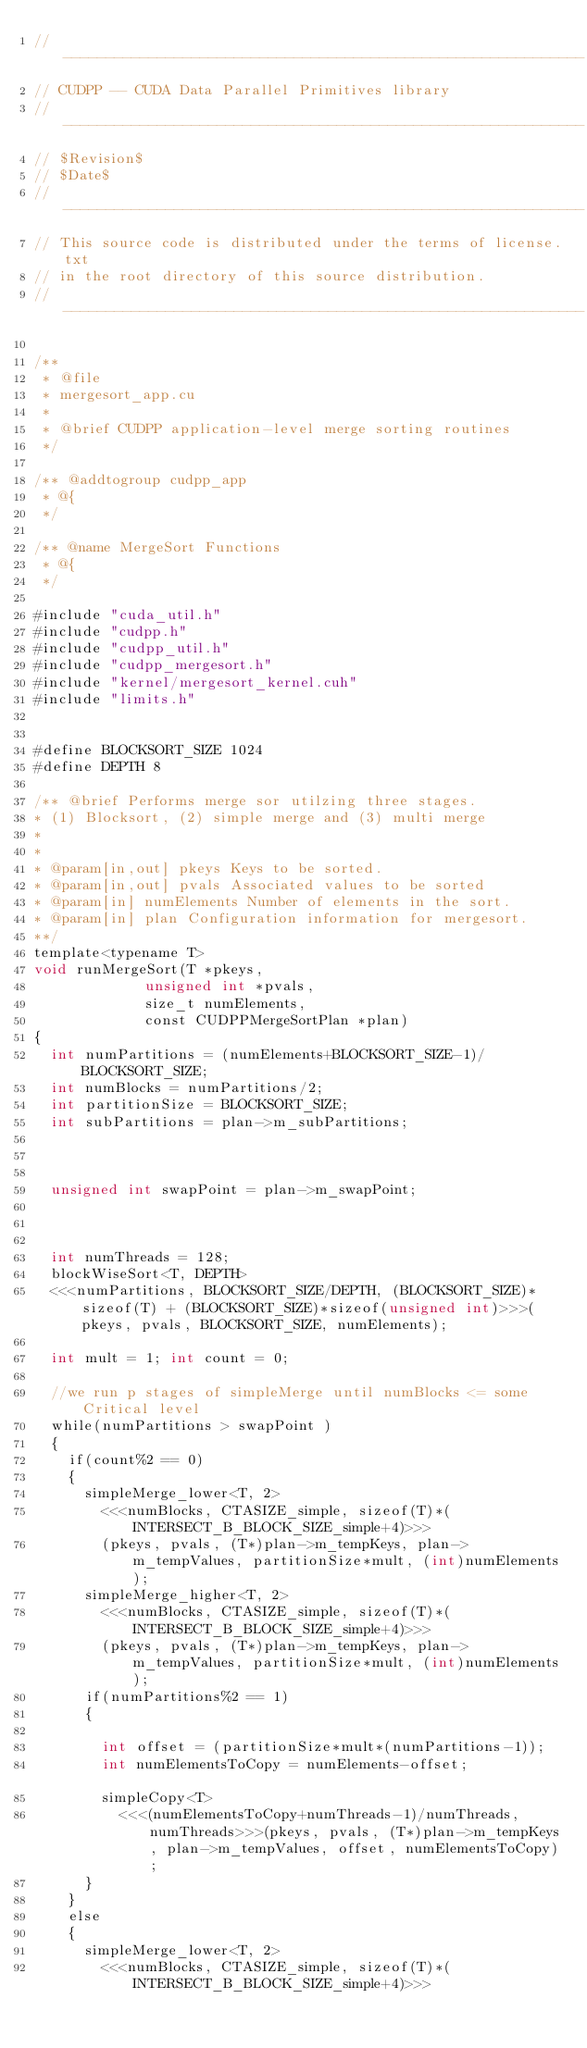<code> <loc_0><loc_0><loc_500><loc_500><_Cuda_>// -------------------------------------------------------------
// CUDPP -- CUDA Data Parallel Primitives library
// -------------------------------------------------------------
// $Revision$
// $Date$
// ------------------------------------------------------------- 
// This source code is distributed under the terms of license.txt 
// in the root directory of this source distribution.
// ------------------------------------------------------------- 

/**
 * @file
 * mergesort_app.cu
 *   
 * @brief CUDPP application-level merge sorting routines
 */

/** @addtogroup cudpp_app 
 * @{
 */

/** @name MergeSort Functions
 * @{
 */
 
#include "cuda_util.h"
#include "cudpp.h"
#include "cudpp_util.h"
#include "cudpp_mergesort.h"
#include "kernel/mergesort_kernel.cuh"
#include "limits.h"


#define BLOCKSORT_SIZE 1024
#define DEPTH 8

/** @brief Performs merge sor utilzing three stages. 
* (1) Blocksort, (2) simple merge and (3) multi merge
* 
* 
* @param[in,out] pkeys Keys to be sorted.
* @param[in,out] pvals Associated values to be sorted
* @param[in] numElements Number of elements in the sort.
* @param[in] plan Configuration information for mergesort.
**/
template<typename T>
void runMergeSort(T *pkeys, 
             unsigned int *pvals,
             size_t numElements, 
             const CUDPPMergeSortPlan *plan)
{
	int numPartitions = (numElements+BLOCKSORT_SIZE-1)/BLOCKSORT_SIZE;
	int numBlocks = numPartitions/2;
	int partitionSize = BLOCKSORT_SIZE;
	int subPartitions = plan->m_subPartitions;
	
		
	
	unsigned int swapPoint = plan->m_swapPoint;
	
	

	int numThreads = 128;	
	blockWiseSort<T, DEPTH>
	<<<numPartitions, BLOCKSORT_SIZE/DEPTH, (BLOCKSORT_SIZE)*sizeof(T) + (BLOCKSORT_SIZE)*sizeof(unsigned int)>>>(pkeys, pvals, BLOCKSORT_SIZE, numElements);

	int mult = 1; int count = 0;

	//we run p stages of simpleMerge until numBlocks <= some Critical level
	while(numPartitions > swapPoint )
	{				
		if(count%2 == 0)
		{ 				
			simpleMerge_lower<T, 2>
				<<<numBlocks, CTASIZE_simple, sizeof(T)*(INTERSECT_B_BLOCK_SIZE_simple+4)>>>
				(pkeys, pvals, (T*)plan->m_tempKeys, plan->m_tempValues, partitionSize*mult, (int)numElements);				
			simpleMerge_higher<T, 2>
				<<<numBlocks, CTASIZE_simple, sizeof(T)*(INTERSECT_B_BLOCK_SIZE_simple+4)>>>
				(pkeys, pvals, (T*)plan->m_tempKeys, plan->m_tempValues, partitionSize*mult, (int)numElements);		
			if(numPartitions%2 == 1)
			{			
				
				int offset = (partitionSize*mult*(numPartitions-1));
				int numElementsToCopy = numElements-offset;												
				simpleCopy<T>
					<<<(numElementsToCopy+numThreads-1)/numThreads, numThreads>>>(pkeys, pvals, (T*)plan->m_tempKeys, plan->m_tempValues, offset, numElementsToCopy);
			}
		}
		else
		{			
			simpleMerge_lower<T, 2>
				<<<numBlocks, CTASIZE_simple, sizeof(T)*(INTERSECT_B_BLOCK_SIZE_simple+4)>>></code> 